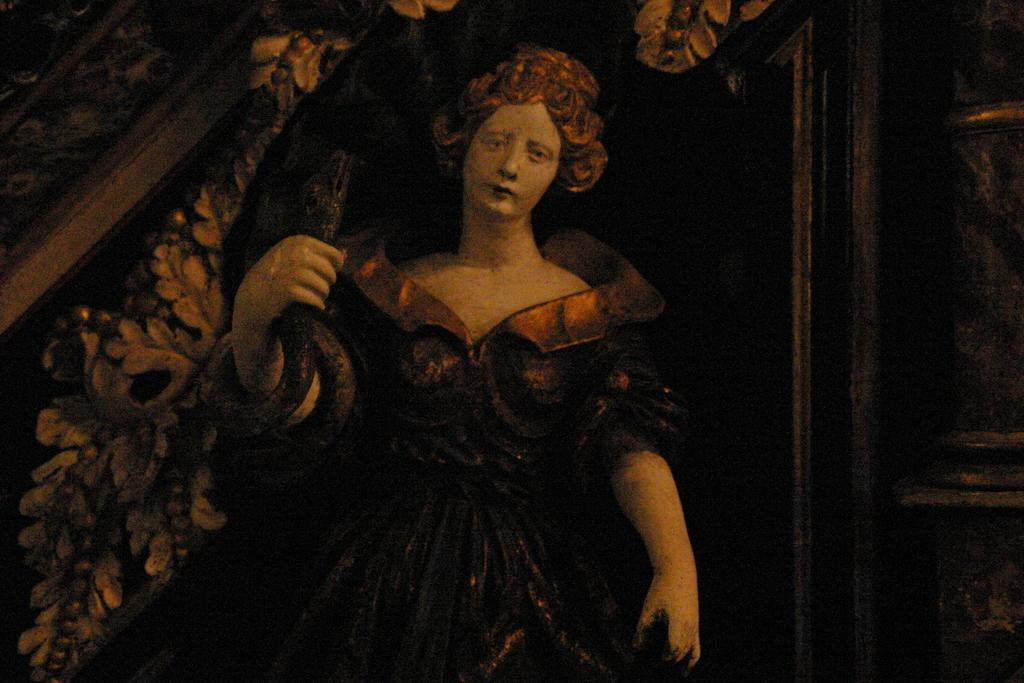What is the main subject of the image? There is a painting in the image. What does the painting depict? The painting depicts a person. How many clocks are hanging on the wall in the painting? There are no clocks visible in the painting; it depicts a person. Is there a net and ball visible in the painting? There is no net or ball present in the painting; it depicts a person. 